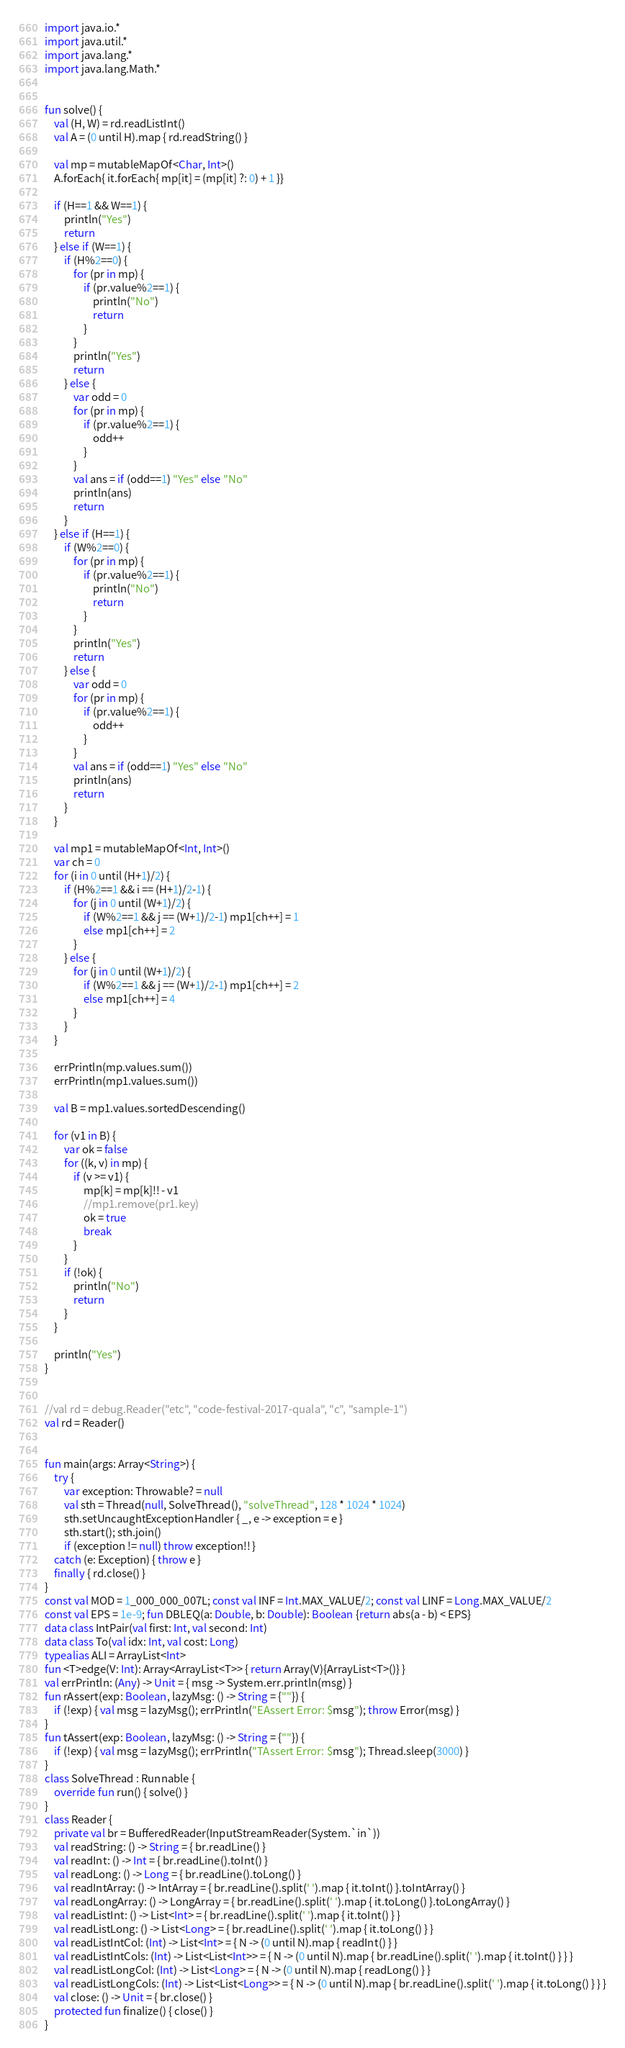<code> <loc_0><loc_0><loc_500><loc_500><_Kotlin_>import java.io.*
import java.util.*
import java.lang.*
import java.lang.Math.*


fun solve() {
    val (H, W) = rd.readListInt()
    val A = (0 until H).map { rd.readString() }

    val mp = mutableMapOf<Char, Int>()
    A.forEach{ it.forEach{ mp[it] = (mp[it] ?: 0) + 1 }}

    if (H==1 && W==1) {
        println("Yes")
        return
    } else if (W==1) {
        if (H%2==0) {
            for (pr in mp) {
                if (pr.value%2==1) {
                    println("No")
                    return
                }
            }
            println("Yes")
            return
        } else {
            var odd = 0
            for (pr in mp) {
                if (pr.value%2==1) {
                    odd++
                }
            }
            val ans = if (odd==1) "Yes" else "No"
            println(ans)
            return
        }
    } else if (H==1) {
        if (W%2==0) {
            for (pr in mp) {
                if (pr.value%2==1) {
                    println("No")
                    return
                }
            }
            println("Yes")
            return
        } else {
            var odd = 0
            for (pr in mp) {
                if (pr.value%2==1) {
                    odd++
                }
            }
            val ans = if (odd==1) "Yes" else "No"
            println(ans)
            return
        }
    }

    val mp1 = mutableMapOf<Int, Int>()
    var ch = 0
    for (i in 0 until (H+1)/2) {
        if (H%2==1 && i == (H+1)/2-1) {
            for (j in 0 until (W+1)/2) {
                if (W%2==1 && j == (W+1)/2-1) mp1[ch++] = 1
                else mp1[ch++] = 2
            }
        } else {
            for (j in 0 until (W+1)/2) {
                if (W%2==1 && j == (W+1)/2-1) mp1[ch++] = 2
                else mp1[ch++] = 4
            }
        }
    }

    errPrintln(mp.values.sum())
    errPrintln(mp1.values.sum())

    val B = mp1.values.sortedDescending()

    for (v1 in B) {
        var ok = false
        for ((k, v) in mp) {
            if (v >= v1) {
                mp[k] = mp[k]!! - v1
                //mp1.remove(pr1.key)
                ok = true
                break
            }
        }
        if (!ok) {
            println("No")
            return
        }
    }

    println("Yes")
}


//val rd = debug.Reader("etc", "code-festival-2017-quala", "c", "sample-1")
val rd = Reader()


fun main(args: Array<String>) {
    try {
        var exception: Throwable? = null
        val sth = Thread(null, SolveThread(), "solveThread", 128 * 1024 * 1024)
        sth.setUncaughtExceptionHandler { _, e -> exception = e }
        sth.start(); sth.join()
        if (exception != null) throw exception!! }
    catch (e: Exception) { throw e }
    finally { rd.close() }
}
const val MOD = 1_000_000_007L; const val INF = Int.MAX_VALUE/2; const val LINF = Long.MAX_VALUE/2
const val EPS = 1e-9; fun DBLEQ(a: Double, b: Double): Boolean {return abs(a - b) < EPS}
data class IntPair(val first: Int, val second: Int)
data class To(val idx: Int, val cost: Long)
typealias ALI = ArrayList<Int>
fun <T>edge(V: Int): Array<ArrayList<T>> { return Array(V){ArrayList<T>()} }
val errPrintln: (Any) -> Unit = { msg -> System.err.println(msg) }
fun rAssert(exp: Boolean, lazyMsg: () -> String = {""}) {
    if (!exp) { val msg = lazyMsg(); errPrintln("EAssert Error: $msg"); throw Error(msg) }
}
fun tAssert(exp: Boolean, lazyMsg: () -> String = {""}) {
    if (!exp) { val msg = lazyMsg(); errPrintln("TAssert Error: $msg"); Thread.sleep(3000) }
}
class SolveThread : Runnable {
    override fun run() { solve() }
}
class Reader {
    private val br = BufferedReader(InputStreamReader(System.`in`))
    val readString: () -> String = { br.readLine() }
    val readInt: () -> Int = { br.readLine().toInt() }
    val readLong: () -> Long = { br.readLine().toLong() }
    val readIntArray: () -> IntArray = { br.readLine().split(' ').map { it.toInt() }.toIntArray() }
    val readLongArray: () -> LongArray = { br.readLine().split(' ').map { it.toLong() }.toLongArray() }
    val readListInt: () -> List<Int> = { br.readLine().split(' ').map { it.toInt() } }
    val readListLong: () -> List<Long> = { br.readLine().split(' ').map { it.toLong() } }
    val readListIntCol: (Int) -> List<Int> = { N -> (0 until N).map { readInt() } }
    val readListIntCols: (Int) -> List<List<Int>> = { N -> (0 until N).map { br.readLine().split(' ').map { it.toInt() } } }
    val readListLongCol: (Int) -> List<Long> = { N -> (0 until N).map { readLong() } }
    val readListLongCols: (Int) -> List<List<Long>> = { N -> (0 until N).map { br.readLine().split(' ').map { it.toLong() } } }
    val close: () -> Unit = { br.close() }
    protected fun finalize() { close() }
}
</code> 